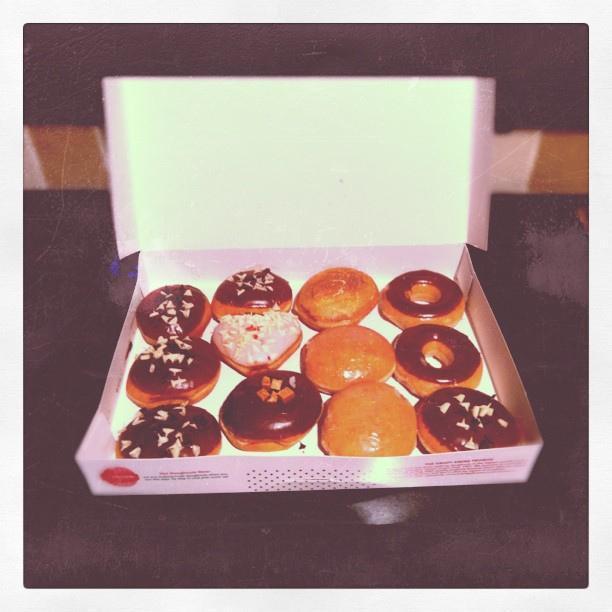How many donuts are chocolate?
Give a very brief answer. 8. How many donuts is on the plate?
Give a very brief answer. 12. How many donuts can be seen?
Give a very brief answer. 12. How many people are holding a surfboard?
Give a very brief answer. 0. 